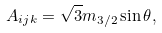<formula> <loc_0><loc_0><loc_500><loc_500>A _ { i j k } = \sqrt { 3 } m _ { 3 / 2 } \sin \theta ,</formula> 